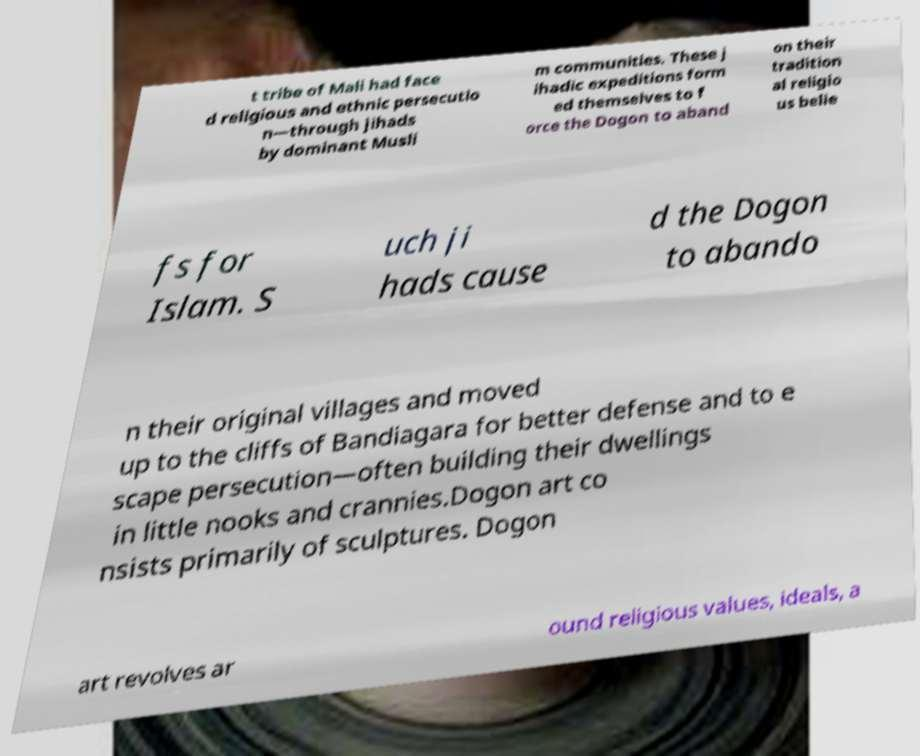Can you accurately transcribe the text from the provided image for me? t tribe of Mali had face d religious and ethnic persecutio n—through jihads by dominant Musli m communities. These j ihadic expeditions form ed themselves to f orce the Dogon to aband on their tradition al religio us belie fs for Islam. S uch ji hads cause d the Dogon to abando n their original villages and moved up to the cliffs of Bandiagara for better defense and to e scape persecution—often building their dwellings in little nooks and crannies.Dogon art co nsists primarily of sculptures. Dogon art revolves ar ound religious values, ideals, a 